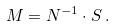Convert formula to latex. <formula><loc_0><loc_0><loc_500><loc_500>M = N ^ { - 1 } \cdot S \, .</formula> 